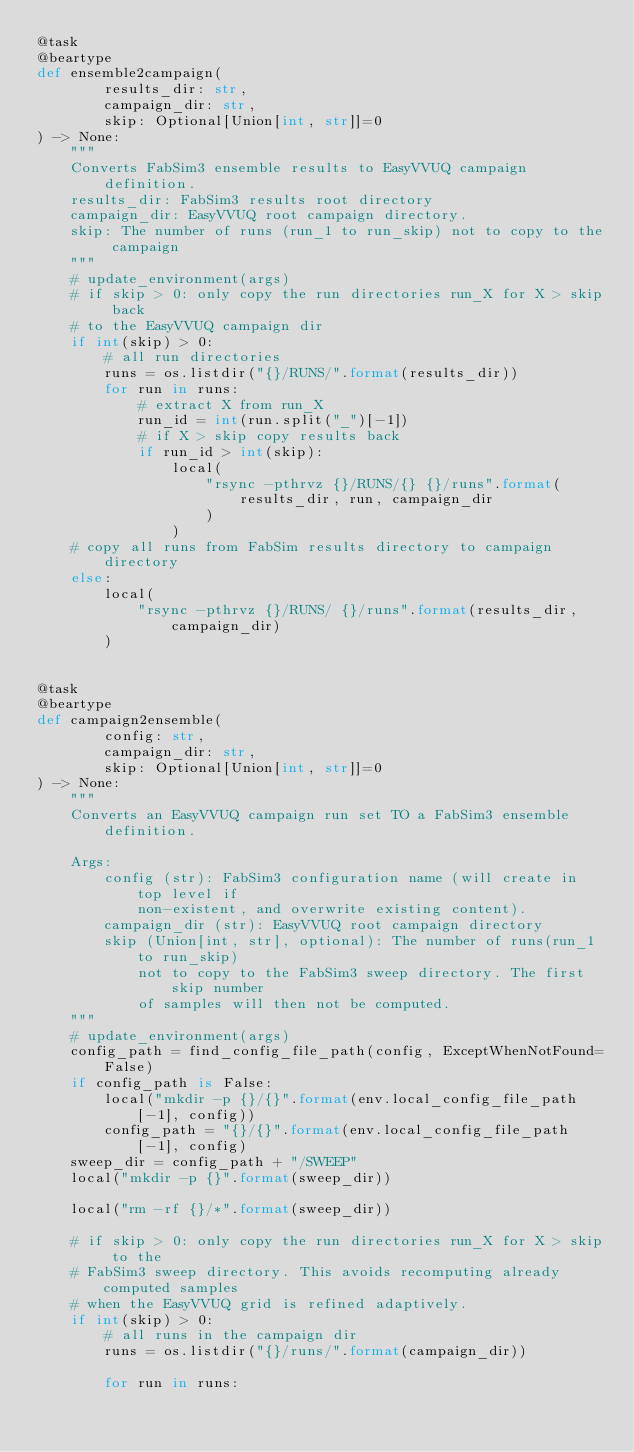Convert code to text. <code><loc_0><loc_0><loc_500><loc_500><_Python_>@task
@beartype
def ensemble2campaign(
        results_dir: str,
        campaign_dir: str,
        skip: Optional[Union[int, str]]=0
) -> None:
    """
    Converts FabSim3 ensemble results to EasyVVUQ campaign definition.
    results_dir: FabSim3 results root directory
    campaign_dir: EasyVVUQ root campaign directory.
    skip: The number of runs (run_1 to run_skip) not to copy to the campaign
    """
    # update_environment(args)
    # if skip > 0: only copy the run directories run_X for X > skip back
    # to the EasyVVUQ campaign dir
    if int(skip) > 0:
        # all run directories
        runs = os.listdir("{}/RUNS/".format(results_dir))
        for run in runs:
            # extract X from run_X
            run_id = int(run.split("_")[-1])
            # if X > skip copy results back
            if run_id > int(skip):
                local(
                    "rsync -pthrvz {}/RUNS/{} {}/runs".format(
                        results_dir, run, campaign_dir
                    )
                )
    # copy all runs from FabSim results directory to campaign directory
    else:
        local(
            "rsync -pthrvz {}/RUNS/ {}/runs".format(results_dir, campaign_dir)
        )


@task
@beartype
def campaign2ensemble(
        config: str,
        campaign_dir: str,
        skip: Optional[Union[int, str]]=0
) -> None:
    """
    Converts an EasyVVUQ campaign run set TO a FabSim3 ensemble definition.

    Args:
        config (str): FabSim3 configuration name (will create in top level if
            non-existent, and overwrite existing content).
        campaign_dir (str): EasyVVUQ root campaign directory
        skip (Union[int, str], optional): The number of runs(run_1 to run_skip)
            not to copy to the FabSim3 sweep directory. The first skip number
            of samples will then not be computed.
    """
    # update_environment(args)
    config_path = find_config_file_path(config, ExceptWhenNotFound=False)
    if config_path is False:
        local("mkdir -p {}/{}".format(env.local_config_file_path[-1], config))
        config_path = "{}/{}".format(env.local_config_file_path[-1], config)
    sweep_dir = config_path + "/SWEEP"
    local("mkdir -p {}".format(sweep_dir))

    local("rm -rf {}/*".format(sweep_dir))

    # if skip > 0: only copy the run directories run_X for X > skip to the
    # FabSim3 sweep directory. This avoids recomputing already computed samples
    # when the EasyVVUQ grid is refined adaptively.
    if int(skip) > 0:
        # all runs in the campaign dir
        runs = os.listdir("{}/runs/".format(campaign_dir))

        for run in runs:</code> 